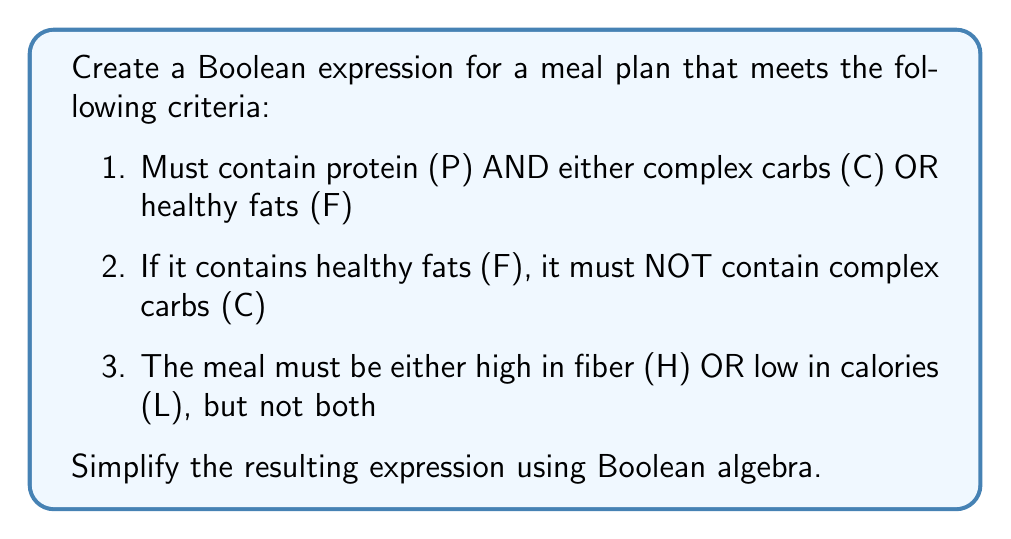Can you solve this math problem? Let's approach this step-by-step:

1. First, let's express each criterion as a Boolean expression:
   a. $P \wedge (C \vee F)$
   b. $F \rightarrow \neg C$, which is equivalent to $\neg F \vee \neg C$
   c. $(H \vee L) \wedge \neg(H \wedge L)$

2. Now, let's combine these expressions:
   $$(P \wedge (C \vee F)) \wedge (\neg F \vee \neg C) \wedge ((H \vee L) \wedge \neg(H \wedge L))$$

3. Let's focus on simplifying $(P \wedge (C \vee F)) \wedge (\neg F \vee \neg C)$:
   
   $$(P \wedge C \wedge \neg C) \vee (P \wedge C \wedge \neg F) \vee (P \wedge F \wedge \neg F) \vee (P \wedge F \wedge \neg C)$$

4. Simplify further:
   
   $(P \wedge C \wedge \neg F) \vee (P \wedge F \wedge \neg C)$

5. Now our expression is:
   
   $((P \wedge C \wedge \neg F) \vee (P \wedge F \wedge \neg C)) \wedge ((H \vee L) \wedge \neg(H \wedge L))$

6. The term $(H \vee L) \wedge \neg(H \wedge L)$ is the Boolean expression for "exclusive or" (XOR), often denoted as $\oplus$. So we can write our final simplified expression as:

   $((P \wedge C \wedge \neg F) \vee (P \wedge F \wedge \neg C)) \wedge (H \oplus L)$

This expression represents a meal plan that contains protein and either complex carbs (without fats) or healthy fats (without complex carbs), and is either high in fiber or low in calories, but not both.
Answer: $((P \wedge C \wedge \neg F) \vee (P \wedge F \wedge \neg C)) \wedge (H \oplus L)$ 